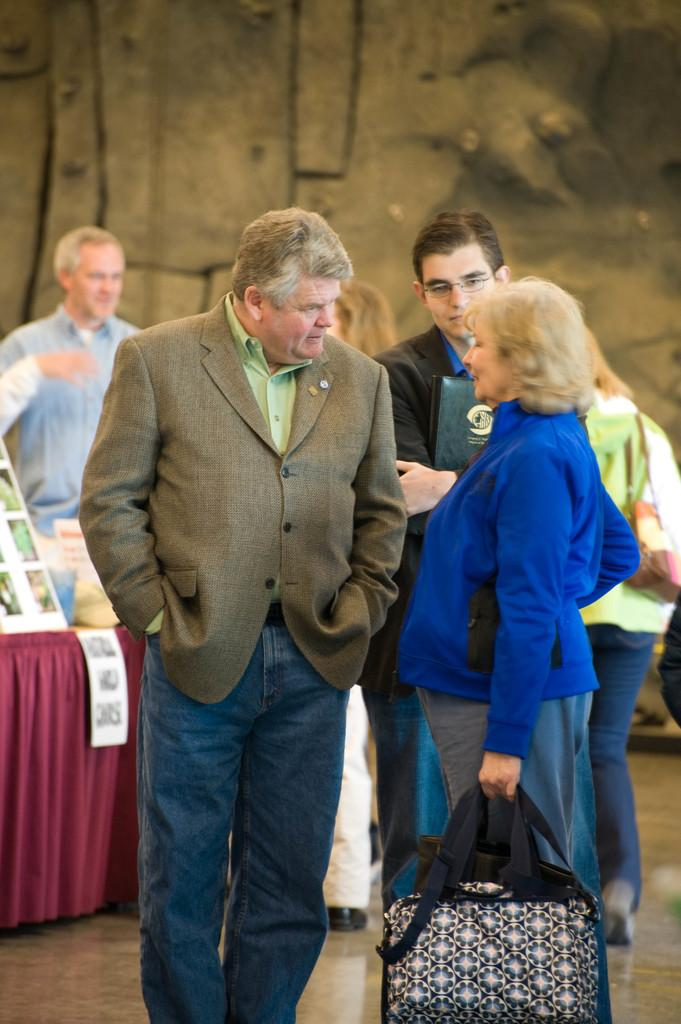What is happening in the image? There are people standing in the image. What can be seen on the table in the background of the image? There are papers on a table in the background of the image. What type of material is visible in the image? There is a cloth visible in the image. What is present in the background of the image? There is a wall in the background of the image. How many houses can be seen in the image? There is no house present in the image; it only features people, papers on a table, a cloth, and a wall in the background. What type of frog is sitting on the cloth in the image? There is no frog present in the image; only the people, papers on a table, a cloth, and a wall in the background are visible. 